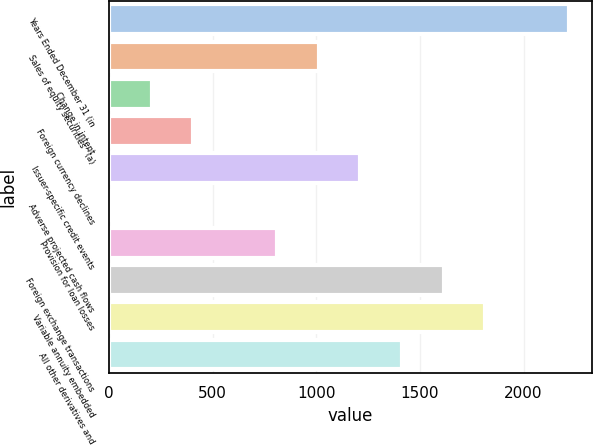<chart> <loc_0><loc_0><loc_500><loc_500><bar_chart><fcel>Years Ended December 31 (in<fcel>Sales of equity securities^(a)<fcel>Change in intent<fcel>Foreign currency declines<fcel>Issuer-specific credit events<fcel>Adverse projected cash flows<fcel>Provision for loan losses<fcel>Foreign exchange transactions<fcel>Variable annuity embedded<fcel>All other derivatives and<nl><fcel>2218.3<fcel>1010.5<fcel>205.3<fcel>406.6<fcel>1211.8<fcel>4<fcel>809.2<fcel>1614.4<fcel>1815.7<fcel>1413.1<nl></chart> 